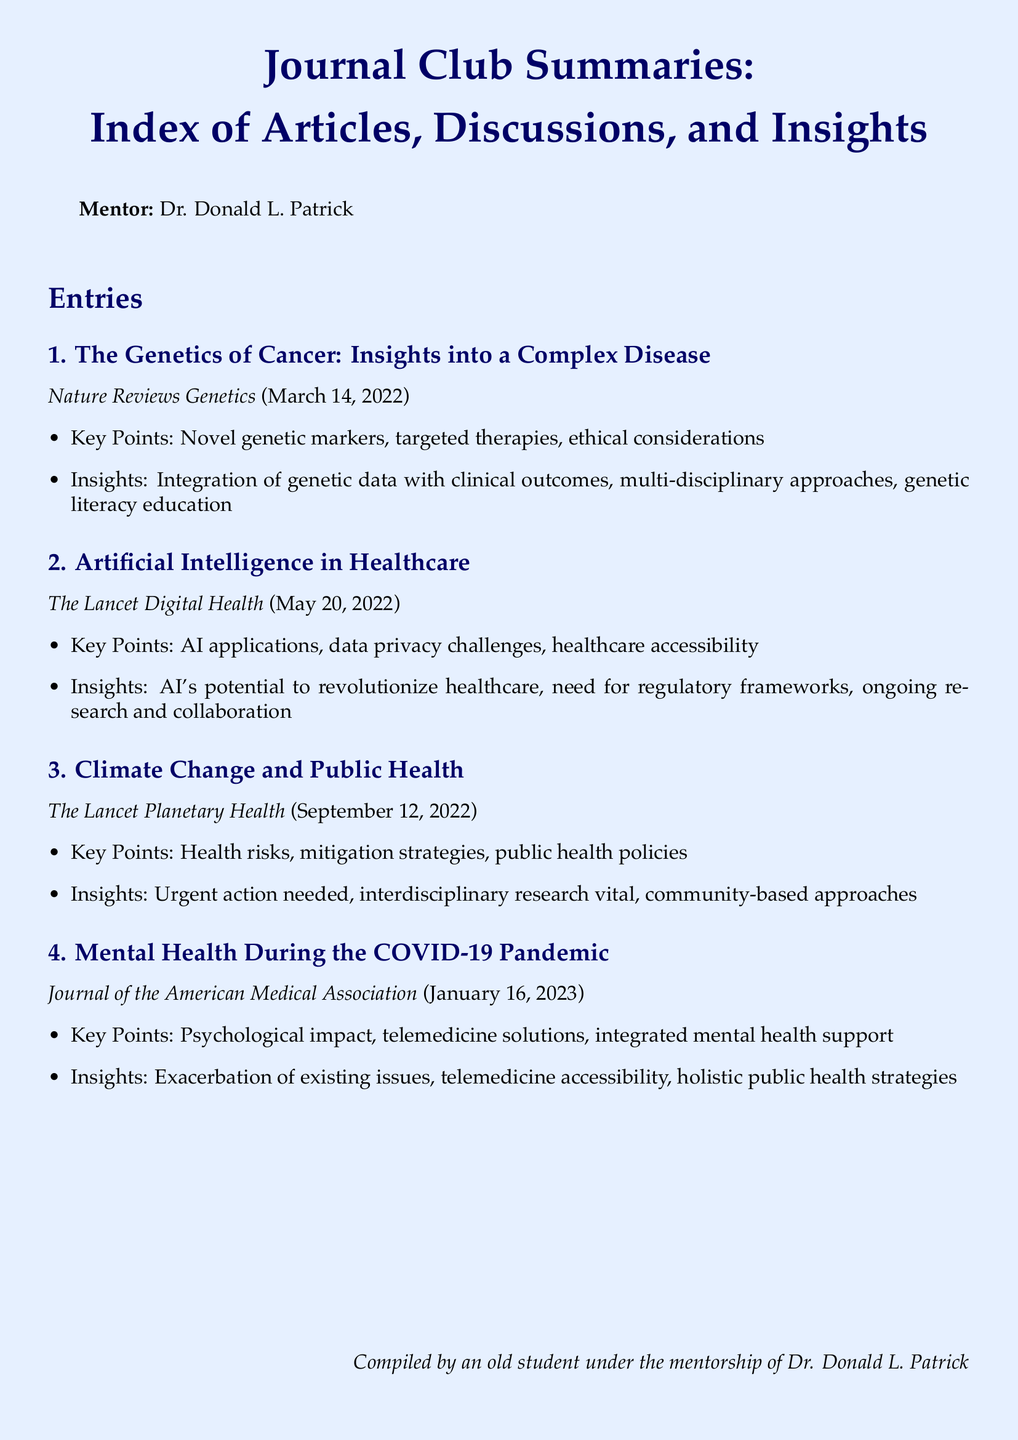What is the title of the first article? The title of the first article is provided in the entries section, specifically mentioning "The Genetics of Cancer: Insights into a Complex Disease."
Answer: The Genetics of Cancer: Insights into a Complex Disease What is the publication date of the second article? The publication date is mentioned with each article entry in the document, and for the second article, it is "May 20, 2022."
Answer: May 20, 2022 What are the key points discussed in the third article? The key points are outlined in bullet points under each article summary, and for the third article, they include "Health risks, mitigation strategies, public health policies."
Answer: Health risks, mitigation strategies, public health policies Who is the mentor mentioned in the document? The document explicitly states the mentor's name at the beginning, identifying him as Dr. Donald L. Patrick.
Answer: Dr. Donald L. Patrick What insight was gained from the article about Mental Health During the COVID-19 Pandemic? Insights from articles are summarized in the entries, and for this article, one insight is "Exacerbation of existing issues."
Answer: Exacerbation of existing issues 